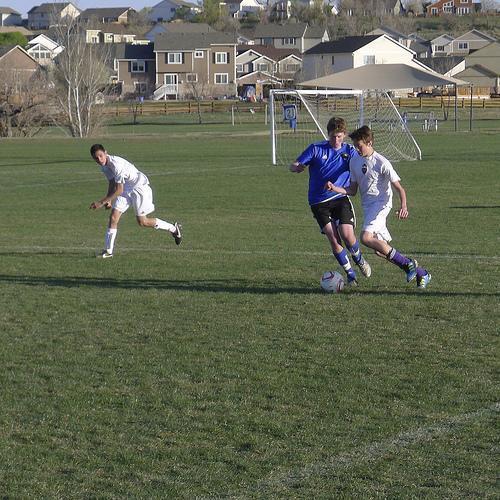How many players?
Give a very brief answer. 3. 